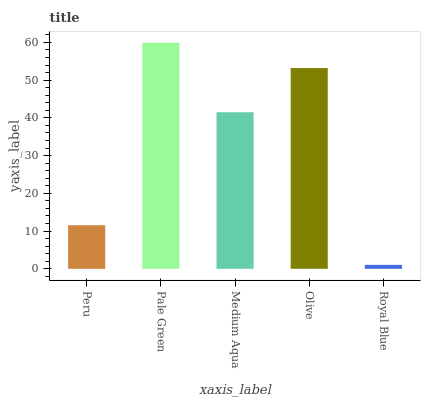Is Medium Aqua the minimum?
Answer yes or no. No. Is Medium Aqua the maximum?
Answer yes or no. No. Is Pale Green greater than Medium Aqua?
Answer yes or no. Yes. Is Medium Aqua less than Pale Green?
Answer yes or no. Yes. Is Medium Aqua greater than Pale Green?
Answer yes or no. No. Is Pale Green less than Medium Aqua?
Answer yes or no. No. Is Medium Aqua the high median?
Answer yes or no. Yes. Is Medium Aqua the low median?
Answer yes or no. Yes. Is Royal Blue the high median?
Answer yes or no. No. Is Royal Blue the low median?
Answer yes or no. No. 